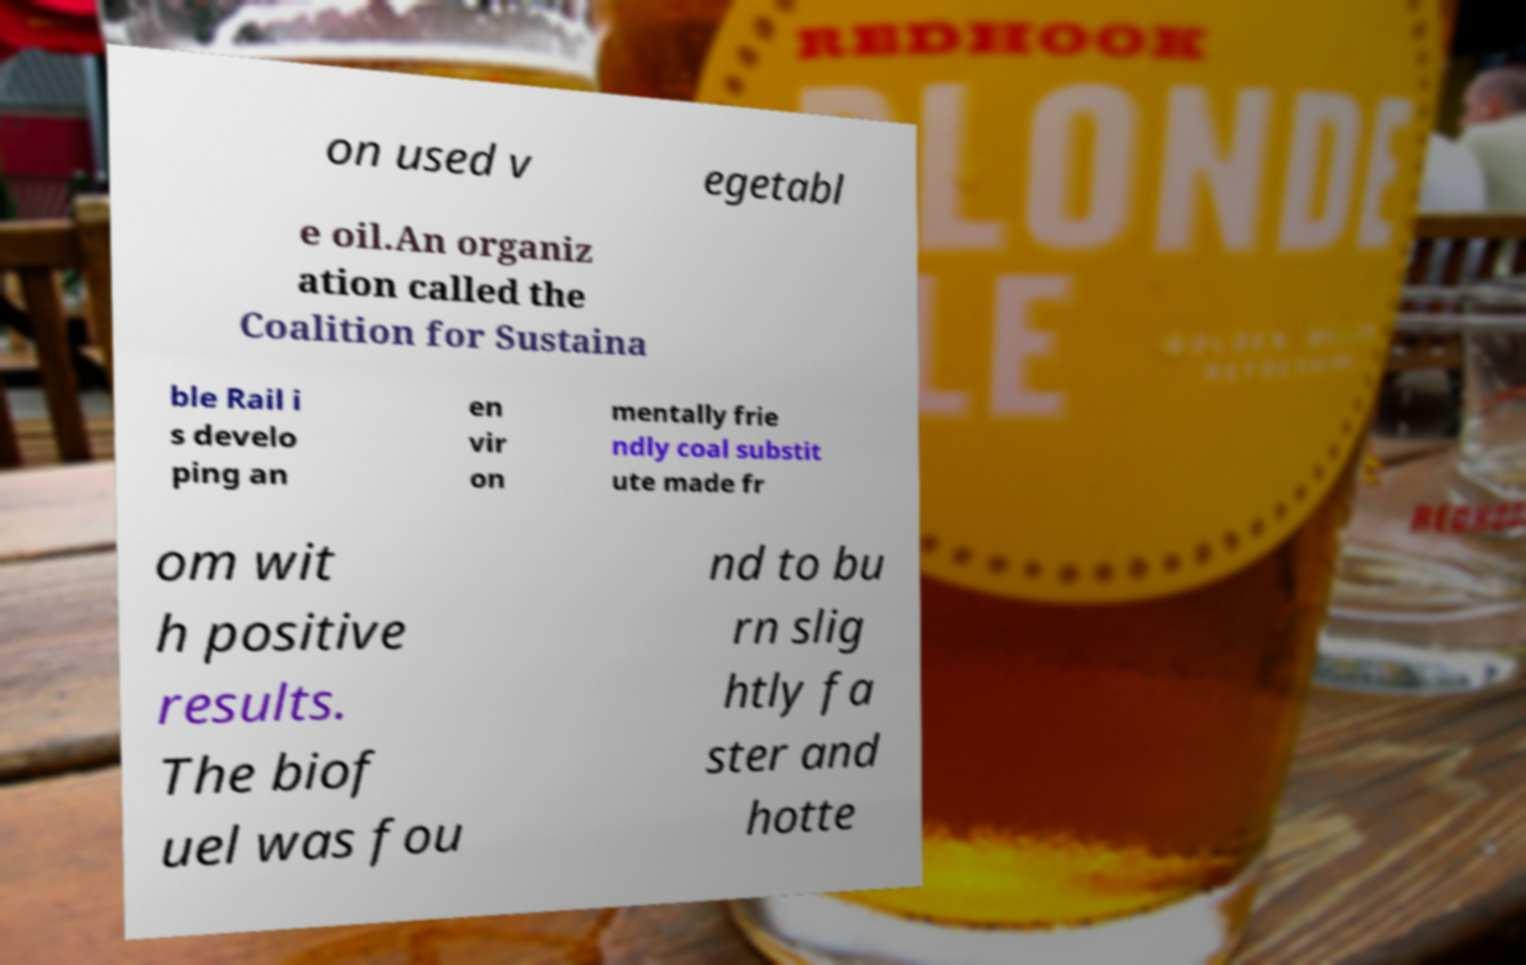Can you read and provide the text displayed in the image?This photo seems to have some interesting text. Can you extract and type it out for me? on used v egetabl e oil.An organiz ation called the Coalition for Sustaina ble Rail i s develo ping an en vir on mentally frie ndly coal substit ute made fr om wit h positive results. The biof uel was fou nd to bu rn slig htly fa ster and hotte 